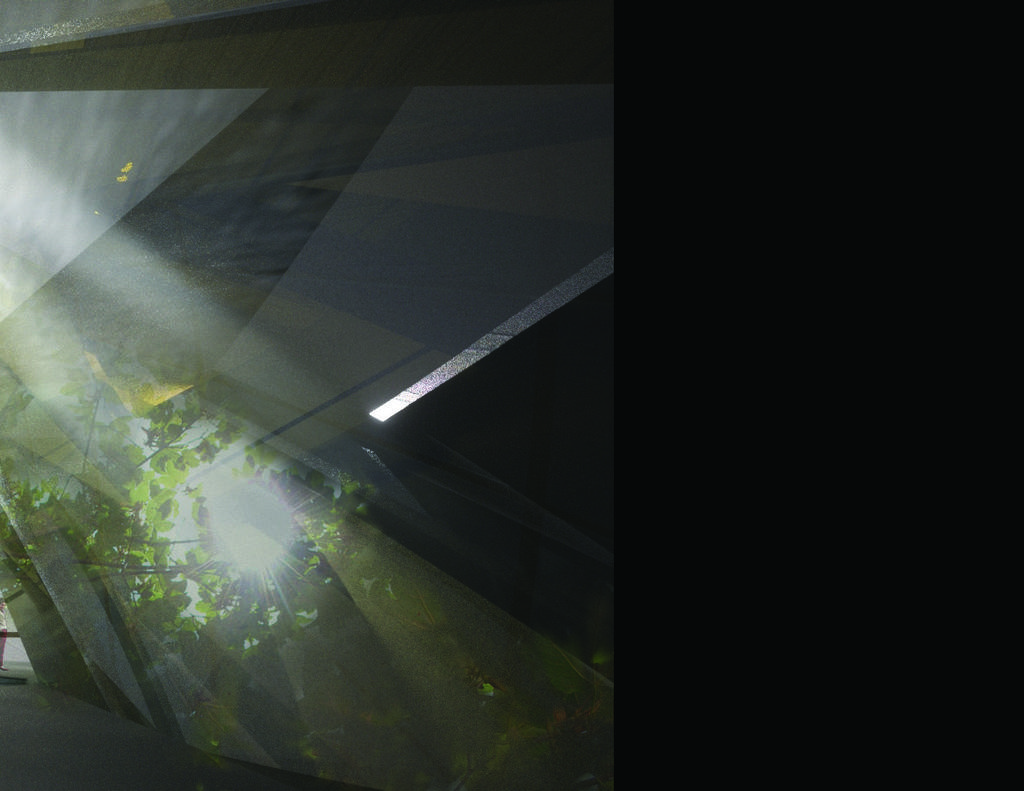What type of natural elements can be seen in the image? There are trees in the image. What is the source of illumination in the image? There is light in the image. Can you describe the object in the image? There is an object in the image, but its specific details are not mentioned in the facts. How would you describe the overall appearance of the background in the image? The background of the image is dark. What is the name of the son who is playing in the shade in the image? There is no son or shade present in the image. 